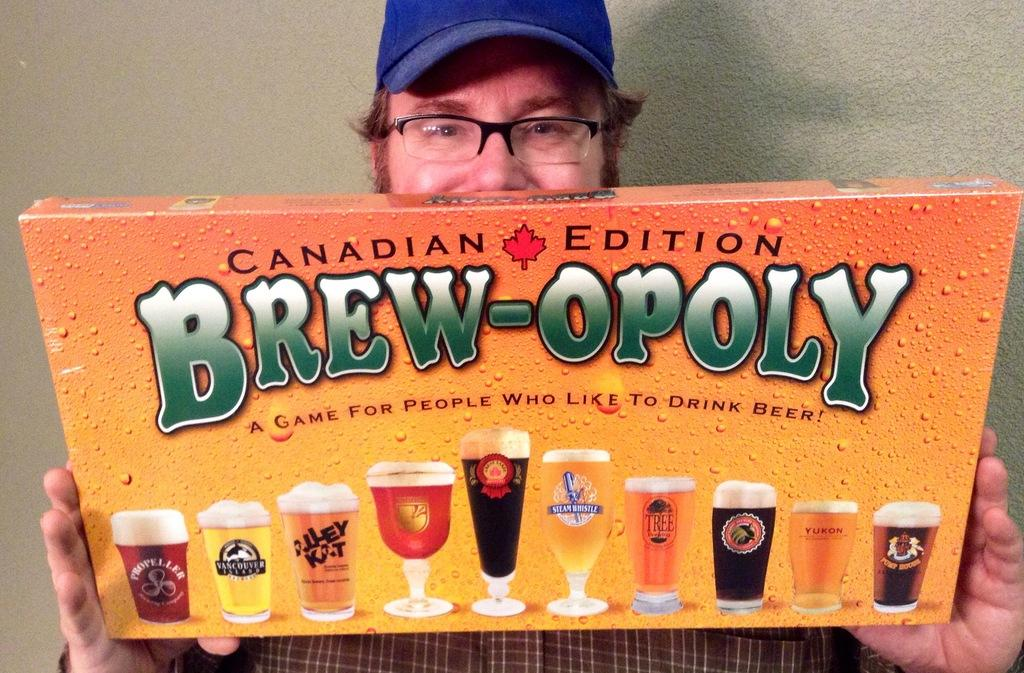<image>
Offer a succinct explanation of the picture presented. A man with a blue hat is holding a game named Brew-Opoly. 